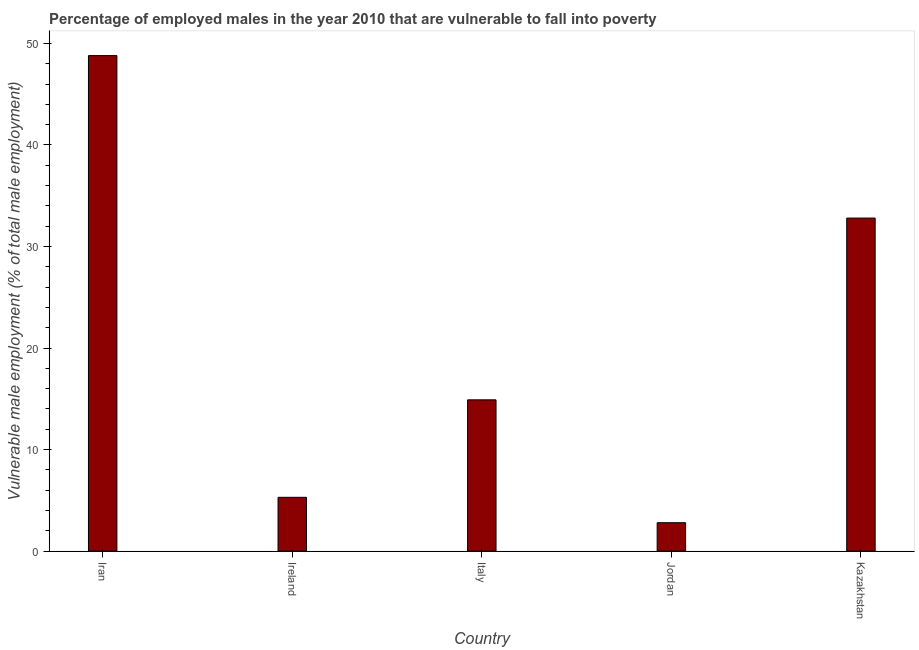Does the graph contain any zero values?
Give a very brief answer. No. What is the title of the graph?
Offer a terse response. Percentage of employed males in the year 2010 that are vulnerable to fall into poverty. What is the label or title of the Y-axis?
Your answer should be compact. Vulnerable male employment (% of total male employment). What is the percentage of employed males who are vulnerable to fall into poverty in Iran?
Ensure brevity in your answer.  48.8. Across all countries, what is the maximum percentage of employed males who are vulnerable to fall into poverty?
Offer a terse response. 48.8. Across all countries, what is the minimum percentage of employed males who are vulnerable to fall into poverty?
Your answer should be compact. 2.8. In which country was the percentage of employed males who are vulnerable to fall into poverty maximum?
Your response must be concise. Iran. In which country was the percentage of employed males who are vulnerable to fall into poverty minimum?
Your answer should be very brief. Jordan. What is the sum of the percentage of employed males who are vulnerable to fall into poverty?
Your answer should be compact. 104.6. What is the difference between the percentage of employed males who are vulnerable to fall into poverty in Ireland and Kazakhstan?
Provide a succinct answer. -27.5. What is the average percentage of employed males who are vulnerable to fall into poverty per country?
Give a very brief answer. 20.92. What is the median percentage of employed males who are vulnerable to fall into poverty?
Your response must be concise. 14.9. In how many countries, is the percentage of employed males who are vulnerable to fall into poverty greater than 38 %?
Give a very brief answer. 1. What is the ratio of the percentage of employed males who are vulnerable to fall into poverty in Iran to that in Italy?
Your answer should be compact. 3.27. Is the percentage of employed males who are vulnerable to fall into poverty in Iran less than that in Italy?
Provide a short and direct response. No. What is the difference between the highest and the second highest percentage of employed males who are vulnerable to fall into poverty?
Ensure brevity in your answer.  16. Is the sum of the percentage of employed males who are vulnerable to fall into poverty in Iran and Ireland greater than the maximum percentage of employed males who are vulnerable to fall into poverty across all countries?
Give a very brief answer. Yes. How many bars are there?
Provide a short and direct response. 5. Are all the bars in the graph horizontal?
Keep it short and to the point. No. What is the Vulnerable male employment (% of total male employment) of Iran?
Provide a short and direct response. 48.8. What is the Vulnerable male employment (% of total male employment) in Ireland?
Give a very brief answer. 5.3. What is the Vulnerable male employment (% of total male employment) in Italy?
Keep it short and to the point. 14.9. What is the Vulnerable male employment (% of total male employment) in Jordan?
Your response must be concise. 2.8. What is the Vulnerable male employment (% of total male employment) in Kazakhstan?
Your answer should be very brief. 32.8. What is the difference between the Vulnerable male employment (% of total male employment) in Iran and Ireland?
Make the answer very short. 43.5. What is the difference between the Vulnerable male employment (% of total male employment) in Iran and Italy?
Provide a short and direct response. 33.9. What is the difference between the Vulnerable male employment (% of total male employment) in Iran and Kazakhstan?
Make the answer very short. 16. What is the difference between the Vulnerable male employment (% of total male employment) in Ireland and Italy?
Your response must be concise. -9.6. What is the difference between the Vulnerable male employment (% of total male employment) in Ireland and Jordan?
Your answer should be very brief. 2.5. What is the difference between the Vulnerable male employment (% of total male employment) in Ireland and Kazakhstan?
Your answer should be very brief. -27.5. What is the difference between the Vulnerable male employment (% of total male employment) in Italy and Jordan?
Offer a very short reply. 12.1. What is the difference between the Vulnerable male employment (% of total male employment) in Italy and Kazakhstan?
Make the answer very short. -17.9. What is the difference between the Vulnerable male employment (% of total male employment) in Jordan and Kazakhstan?
Give a very brief answer. -30. What is the ratio of the Vulnerable male employment (% of total male employment) in Iran to that in Ireland?
Offer a terse response. 9.21. What is the ratio of the Vulnerable male employment (% of total male employment) in Iran to that in Italy?
Provide a succinct answer. 3.27. What is the ratio of the Vulnerable male employment (% of total male employment) in Iran to that in Jordan?
Your answer should be very brief. 17.43. What is the ratio of the Vulnerable male employment (% of total male employment) in Iran to that in Kazakhstan?
Provide a succinct answer. 1.49. What is the ratio of the Vulnerable male employment (% of total male employment) in Ireland to that in Italy?
Your response must be concise. 0.36. What is the ratio of the Vulnerable male employment (% of total male employment) in Ireland to that in Jordan?
Your response must be concise. 1.89. What is the ratio of the Vulnerable male employment (% of total male employment) in Ireland to that in Kazakhstan?
Offer a terse response. 0.16. What is the ratio of the Vulnerable male employment (% of total male employment) in Italy to that in Jordan?
Give a very brief answer. 5.32. What is the ratio of the Vulnerable male employment (% of total male employment) in Italy to that in Kazakhstan?
Give a very brief answer. 0.45. What is the ratio of the Vulnerable male employment (% of total male employment) in Jordan to that in Kazakhstan?
Your response must be concise. 0.09. 